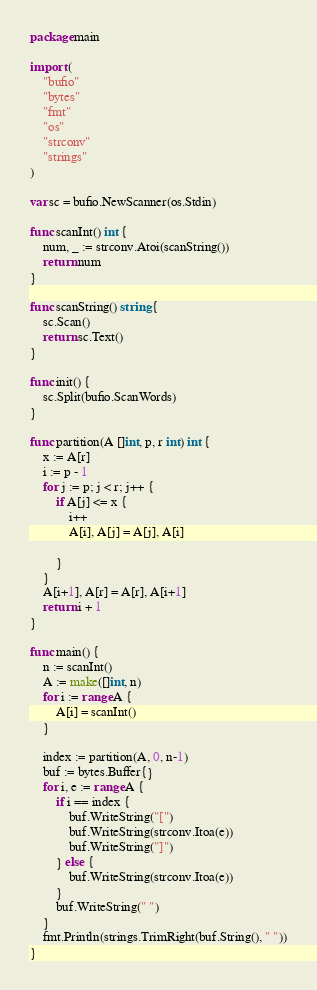Convert code to text. <code><loc_0><loc_0><loc_500><loc_500><_Go_>package main

import (
	"bufio"
	"bytes"
	"fmt"
	"os"
	"strconv"
	"strings"
)

var sc = bufio.NewScanner(os.Stdin)

func scanInt() int {
	num, _ := strconv.Atoi(scanString())
	return num
}

func scanString() string {
	sc.Scan()
	return sc.Text()
}

func init() {
	sc.Split(bufio.ScanWords)
}

func partition(A []int, p, r int) int {
	x := A[r]
	i := p - 1
	for j := p; j < r; j++ {
		if A[j] <= x {
			i++
			A[i], A[j] = A[j], A[i]

		}
	}
	A[i+1], A[r] = A[r], A[i+1]
	return i + 1
}

func main() {
	n := scanInt()
	A := make([]int, n)
	for i := range A {
		A[i] = scanInt()
	}

	index := partition(A, 0, n-1)
	buf := bytes.Buffer{}
	for i, e := range A {
		if i == index {
			buf.WriteString("[")
			buf.WriteString(strconv.Itoa(e))
			buf.WriteString("]")
		} else {
			buf.WriteString(strconv.Itoa(e))
		}
		buf.WriteString(" ")
	}
	fmt.Println(strings.TrimRight(buf.String(), " "))
}

</code> 